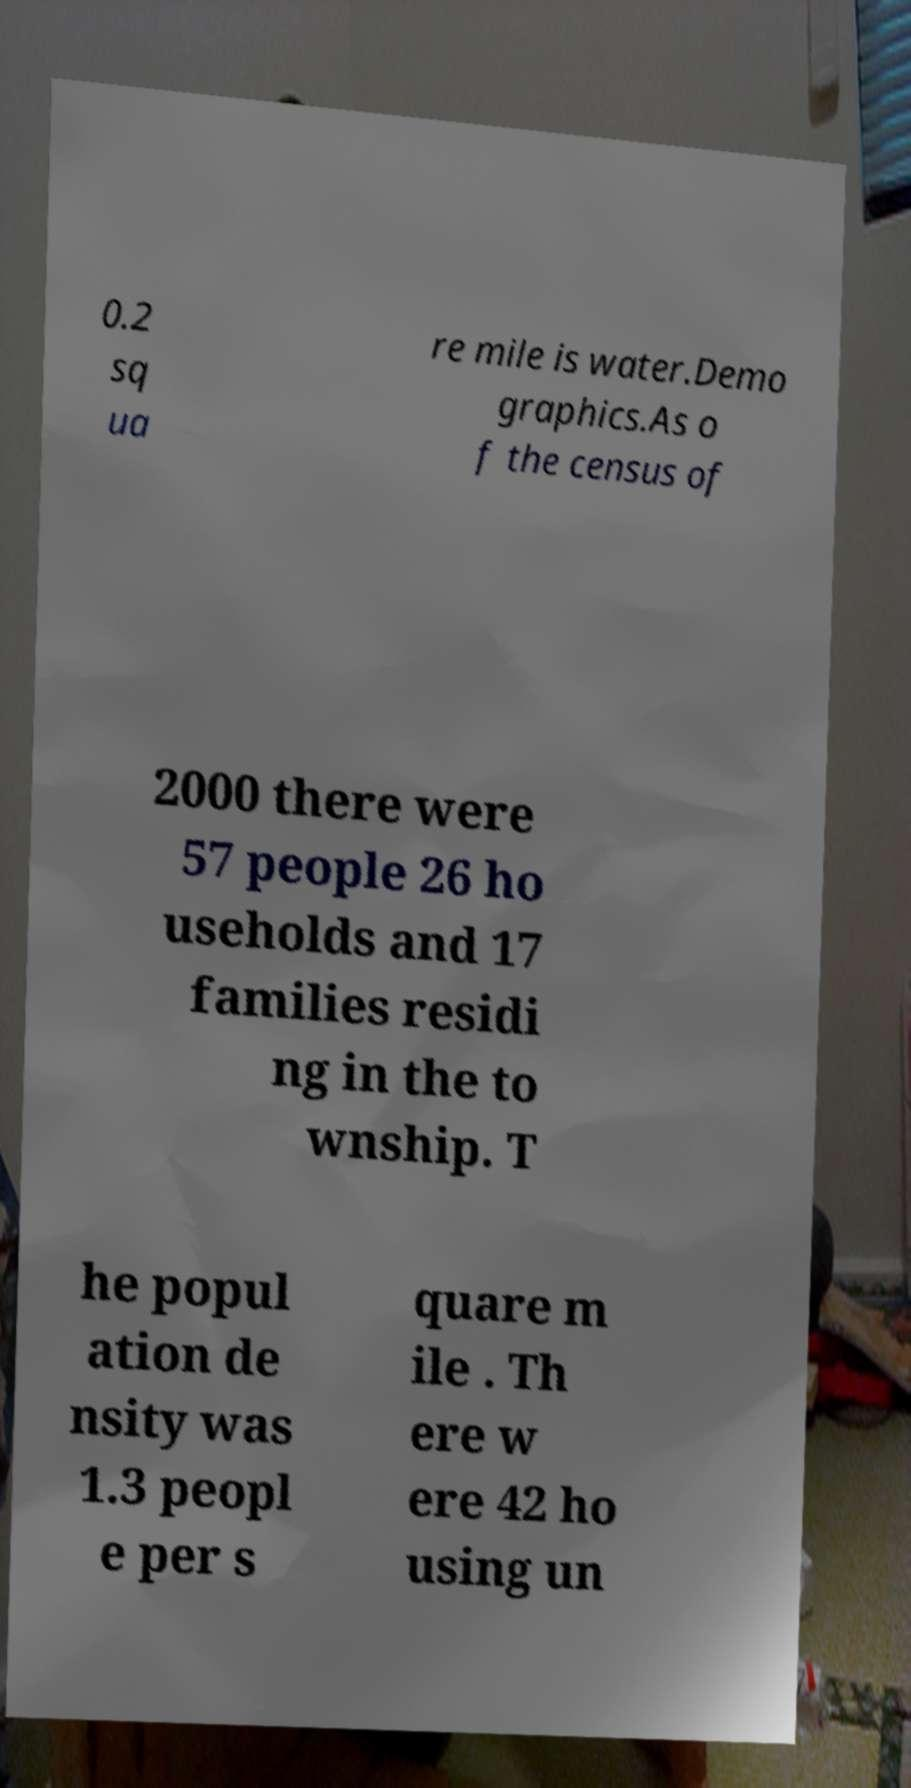Can you accurately transcribe the text from the provided image for me? 0.2 sq ua re mile is water.Demo graphics.As o f the census of 2000 there were 57 people 26 ho useholds and 17 families residi ng in the to wnship. T he popul ation de nsity was 1.3 peopl e per s quare m ile . Th ere w ere 42 ho using un 